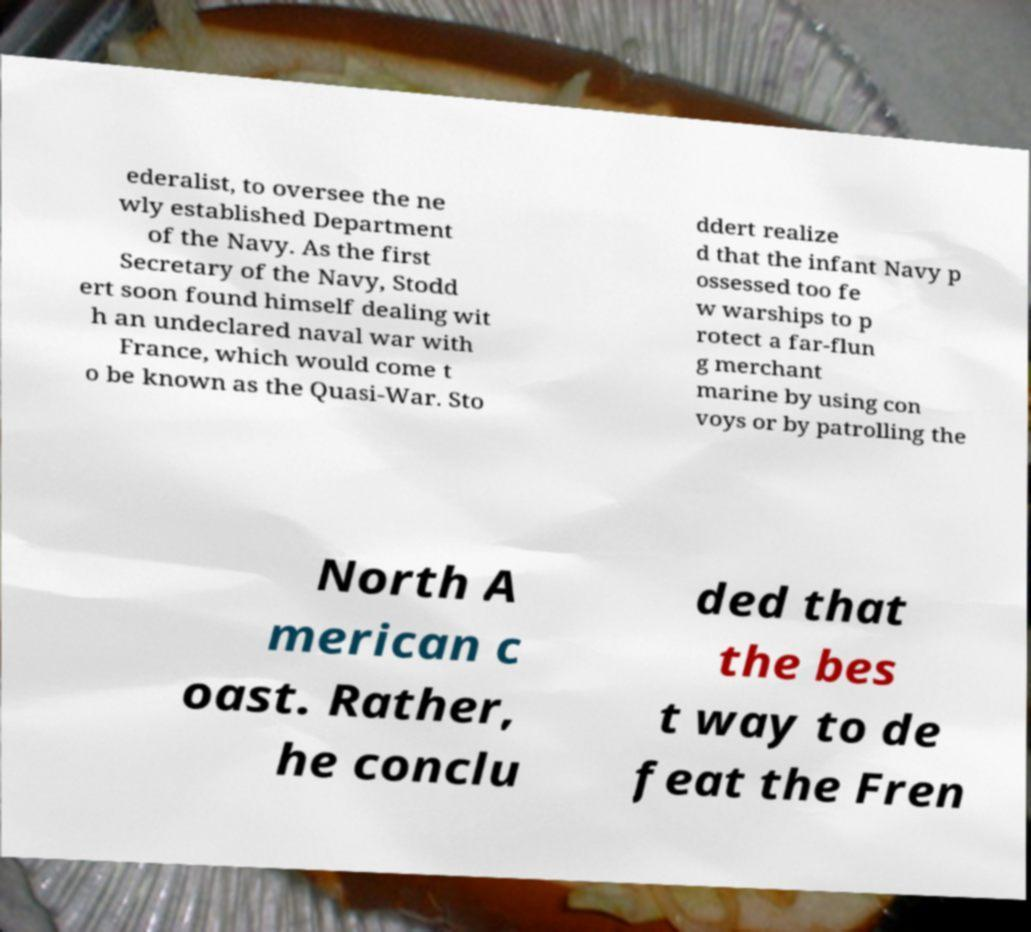Please identify and transcribe the text found in this image. ederalist, to oversee the ne wly established Department of the Navy. As the first Secretary of the Navy, Stodd ert soon found himself dealing wit h an undeclared naval war with France, which would come t o be known as the Quasi-War. Sto ddert realize d that the infant Navy p ossessed too fe w warships to p rotect a far-flun g merchant marine by using con voys or by patrolling the North A merican c oast. Rather, he conclu ded that the bes t way to de feat the Fren 